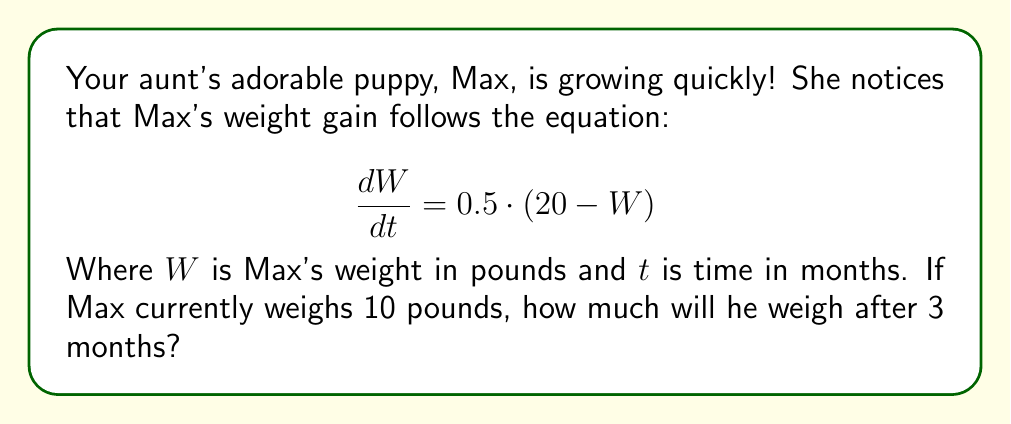Give your solution to this math problem. Let's approach this step-by-step:

1) We're given a first-order differential equation:
   $$\frac{dW}{dt} = 0.5 \cdot (20 - W)$$

2) This is a separable equation. Let's separate the variables:
   $$\frac{dW}{20 - W} = 0.5 \cdot dt$$

3) Now, let's integrate both sides:
   $$\int \frac{dW}{20 - W} = \int 0.5 \cdot dt$$

4) The left side integrates to $-\ln|20 - W|$, and the right side to $0.5t + C$:
   $$-\ln|20 - W| = 0.5t + C$$

5) Let's solve for W:
   $$\ln|20 - W| = -0.5t - C$$
   $$20 - W = e^{-0.5t - C}$$
   $$W = 20 - e^{-0.5t - C}$$

6) We're told that Max currently weighs 10 pounds. Let's use this to find C:
   $$10 = 20 - e^{-0.5(0) - C}$$
   $$10 = 20 - e^{-C}$$
   $$e^{-C} = 10$$
   $$C = -\ln(10)$$

7) Now our equation is:
   $$W = 20 - 10e^{-0.5t}$$

8) To find Max's weight after 3 months, we plug in t = 3:
   $$W = 20 - 10e^{-0.5(3)}$$
   $$W = 20 - 10e^{-1.5}$$
   $$W \approx 15.78$$

Therefore, after 3 months, Max will weigh approximately 15.78 pounds.
Answer: Max will weigh approximately 15.78 pounds after 3 months. 